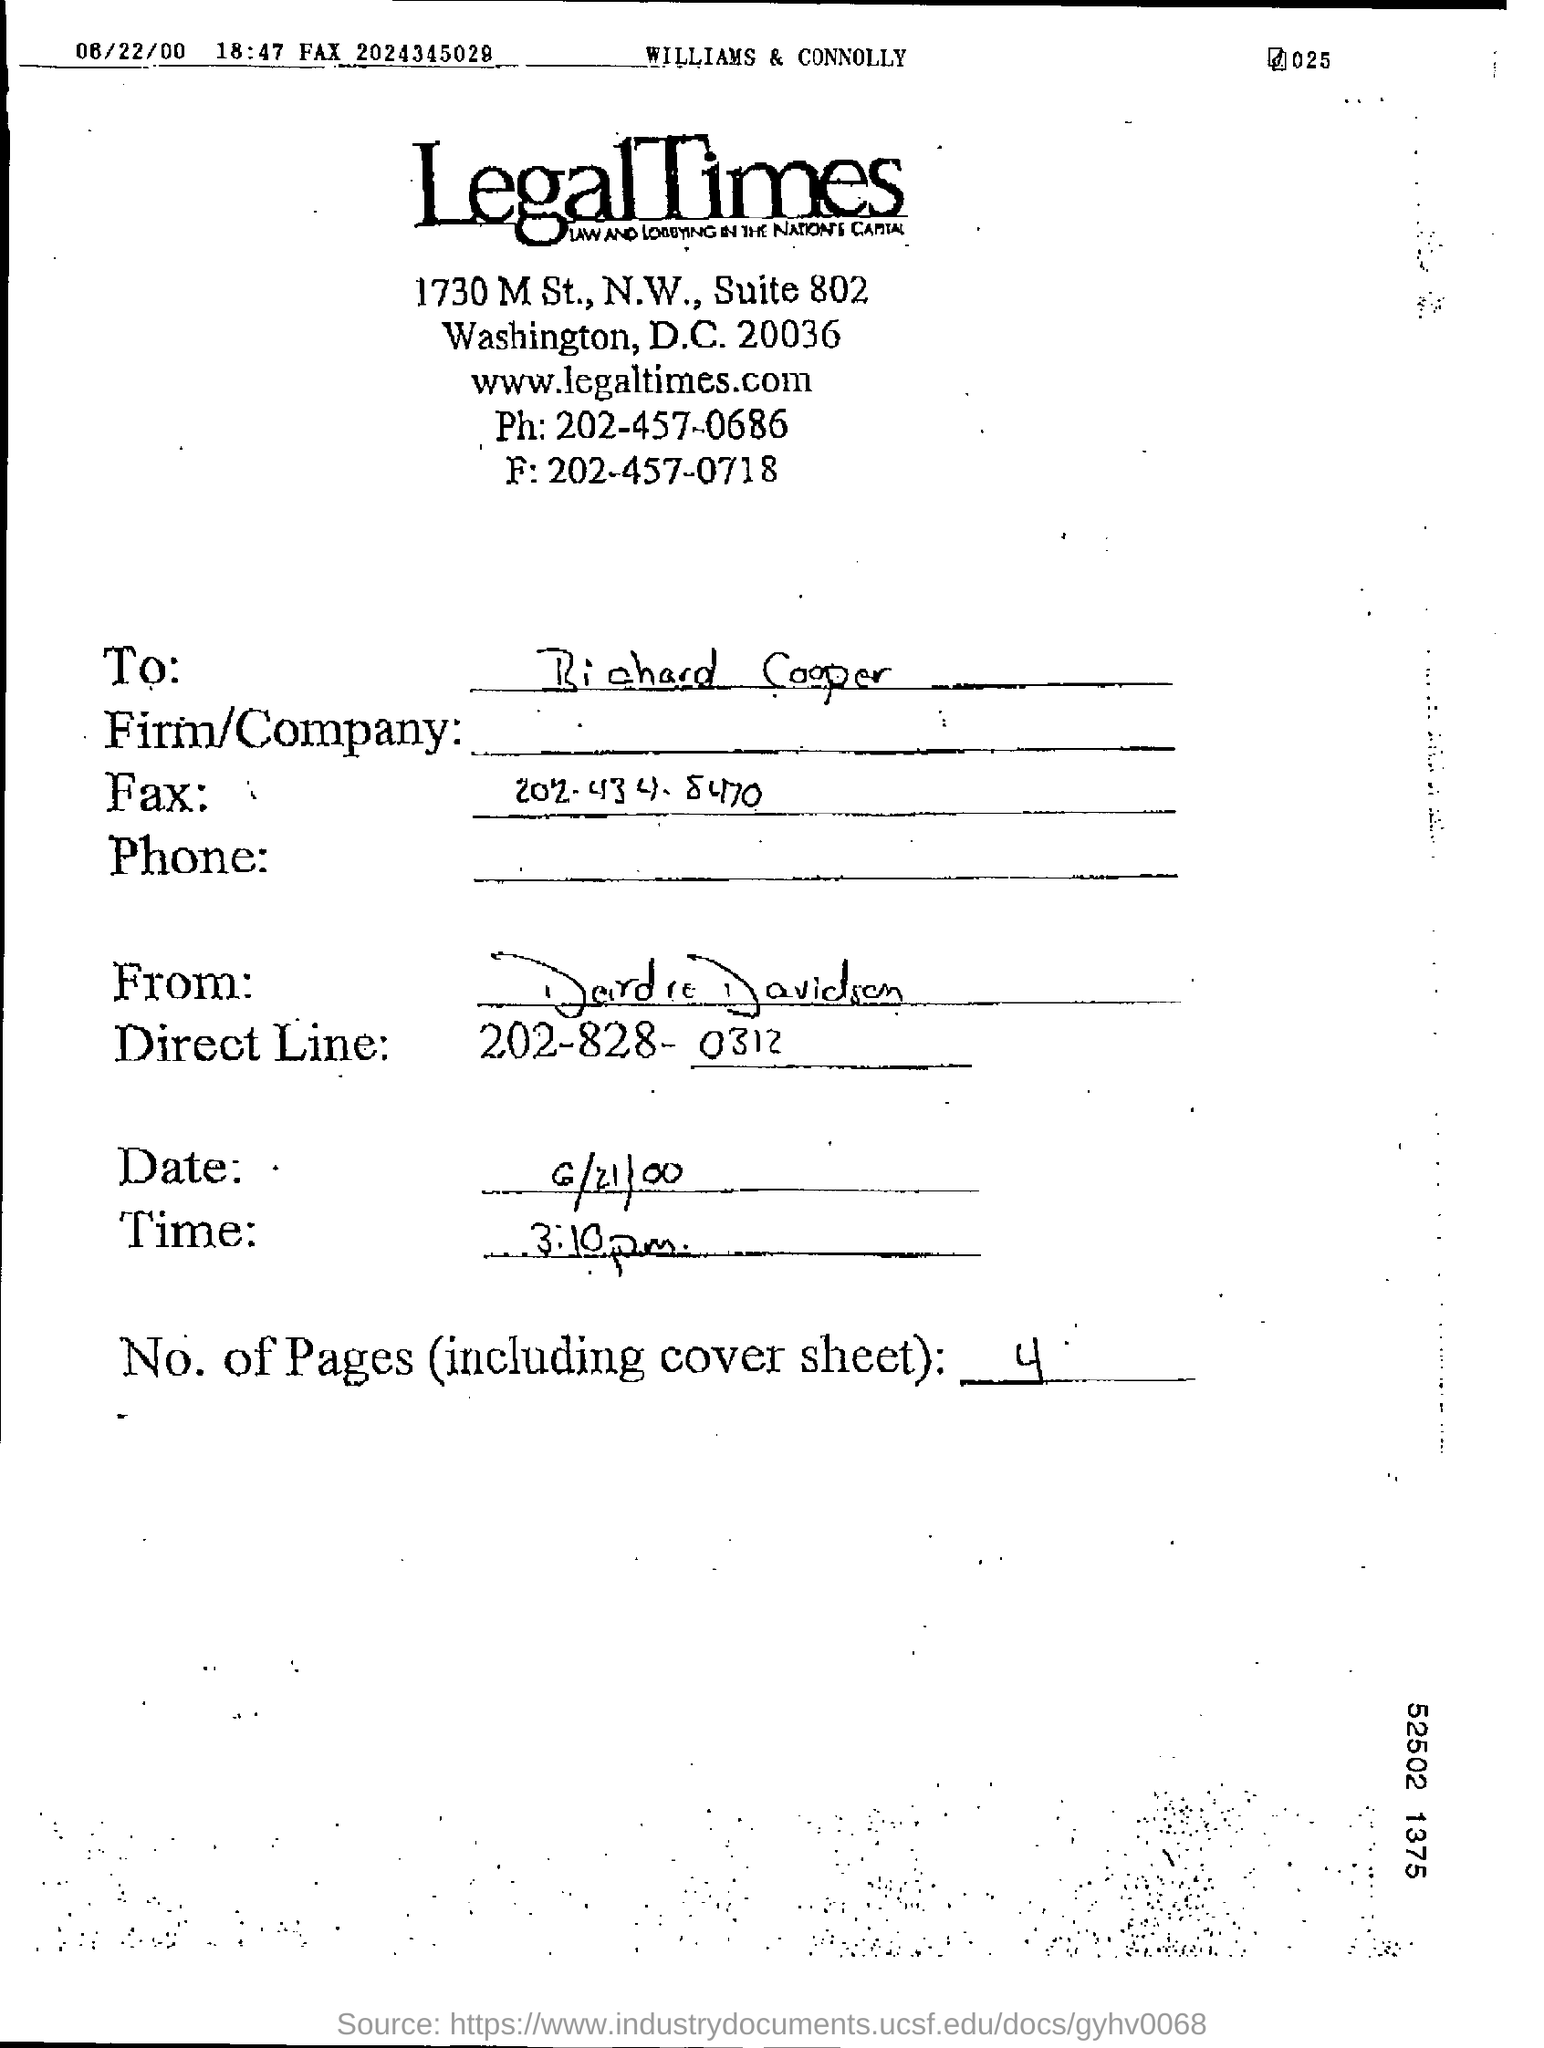Mention a couple of crucial points in this snapshot. There are four pages in this document, including the coversheet. The direct line in the document is 202-828-0312. 